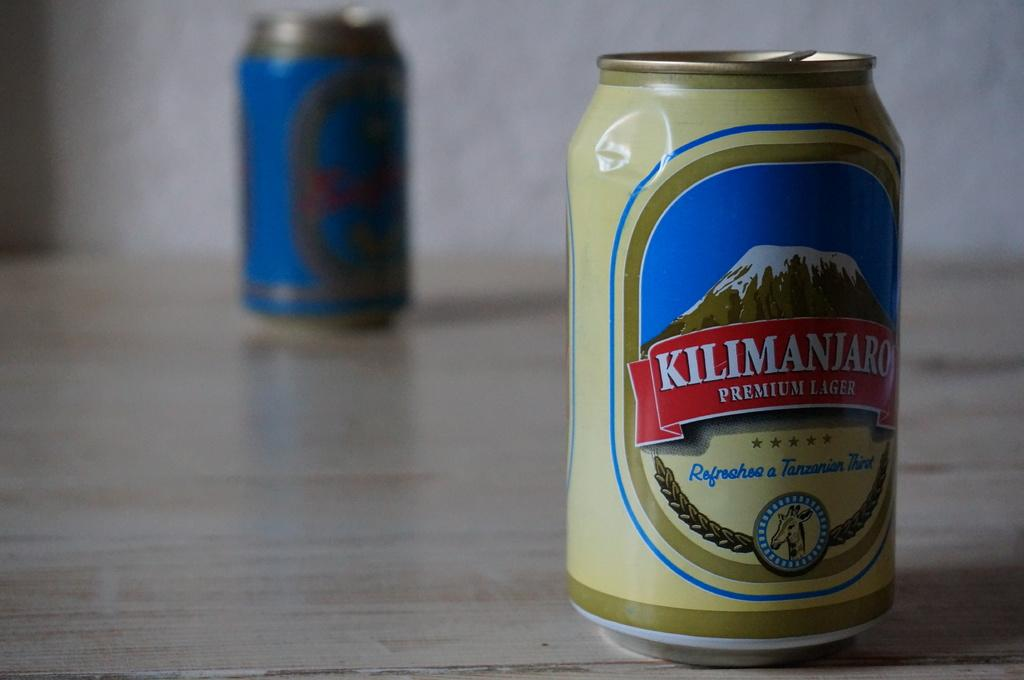<image>
Present a compact description of the photo's key features. A can of Kilimanjaro premium lager sits on a table. 